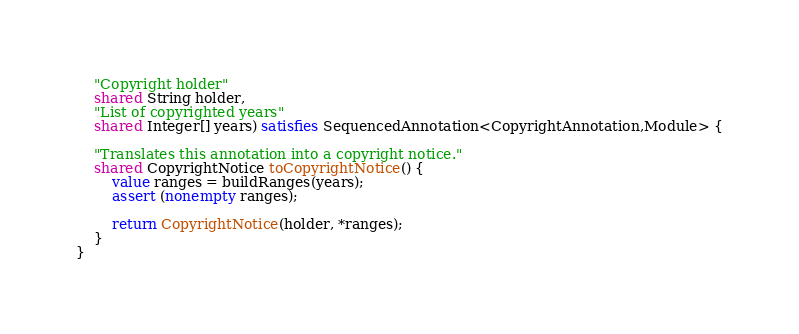<code> <loc_0><loc_0><loc_500><loc_500><_Ceylon_>	"Copyright holder"
	shared String holder,
	"List of copyrighted years"
	shared Integer[] years) satisfies SequencedAnnotation<CopyrightAnnotation,Module> {

	"Translates this annotation into a copyright notice."
	shared CopyrightNotice toCopyrightNotice() {
		value ranges = buildRanges(years);
		assert (nonempty ranges);

		return CopyrightNotice(holder, *ranges);
	}
}
</code> 